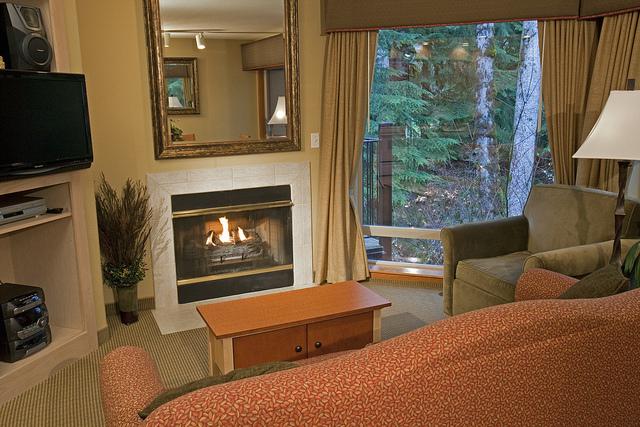What kind of frame is around the mirror?
Short answer required. Gold. Is this a warm colonial style living room?
Be succinct. Yes. What kind of light fixture is visible in the top area of the mirror?
Answer briefly. Track lighting. Is this a hotel room?
Concise answer only. No. What color are the curtains?
Write a very short answer. Tan. Does this room look cold with no personal touches?
Quick response, please. No. What is the accent color used in this room?
Quick response, please. Orange. Is this in a high-rise complex?
Give a very brief answer. No. What color is the sofa?
Be succinct. Orange. What can be seen out the window?
Give a very brief answer. Trees. Where is the white wine?
Be succinct. Nowhere. What room is this?
Be succinct. Living room. Does the photo depict a daytime or nighttime scene?
Be succinct. Daytime. 